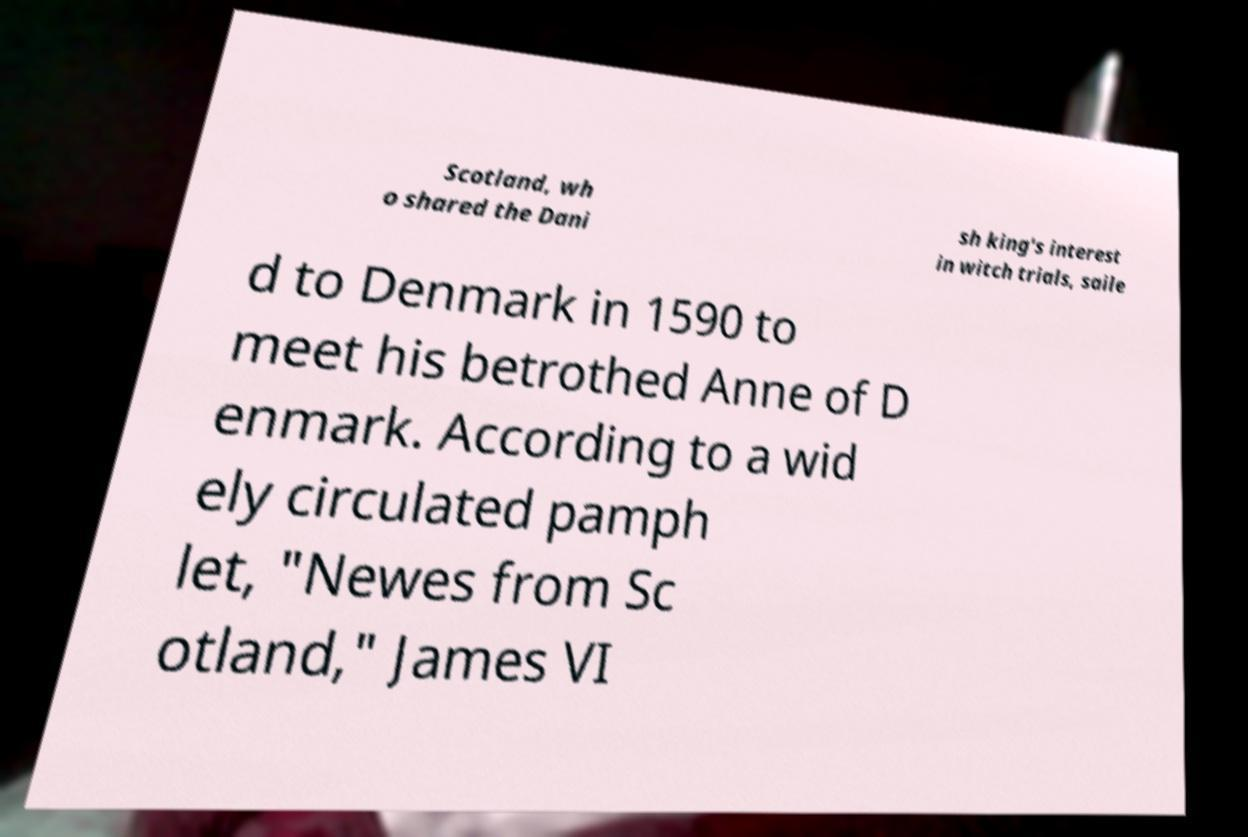For documentation purposes, I need the text within this image transcribed. Could you provide that? Scotland, wh o shared the Dani sh king's interest in witch trials, saile d to Denmark in 1590 to meet his betrothed Anne of D enmark. According to a wid ely circulated pamph let, "Newes from Sc otland," James VI 